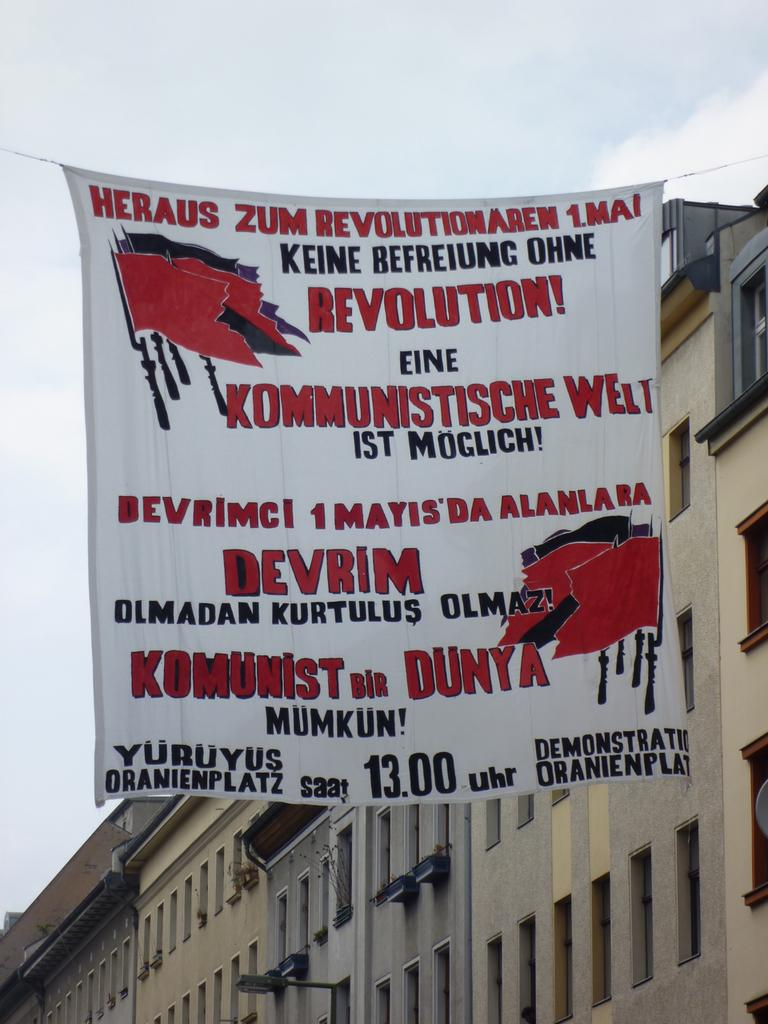What type of structures can be seen in the image? There are buildings in the image. What else is present in the image besides the buildings? There is a banner with text and images in the image. What can be seen in the background of the image? The sky is visible in the image. How many cacti are present in the image? There are no cacti present in the image. What type of van can be seen parked near the buildings? There is no van present in the image. 